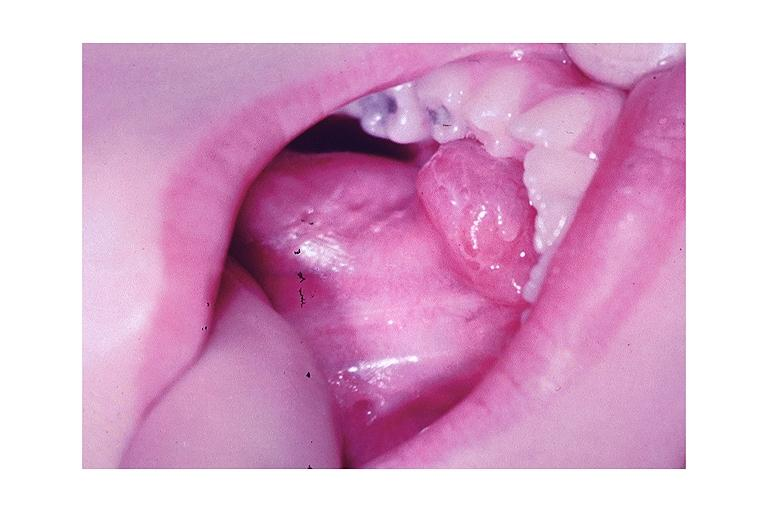s oral present?
Answer the question using a single word or phrase. Yes 